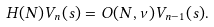<formula> <loc_0><loc_0><loc_500><loc_500>H ( N ) V _ { n } ( s ) = { O } ( N , \nu ) V _ { n - 1 } ( s ) .</formula> 